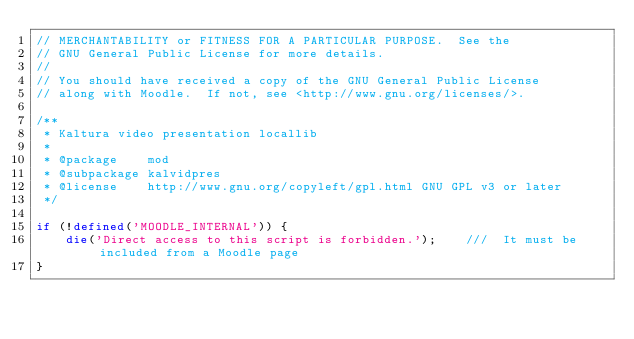Convert code to text. <code><loc_0><loc_0><loc_500><loc_500><_PHP_>// MERCHANTABILITY or FITNESS FOR A PARTICULAR PURPOSE.  See the
// GNU General Public License for more details.
//
// You should have received a copy of the GNU General Public License
// along with Moodle.  If not, see <http://www.gnu.org/licenses/>.

/**
 * Kaltura video presentation locallib
 *
 * @package    mod
 * @subpackage kalvidpres
 * @license    http://www.gnu.org/copyleft/gpl.html GNU GPL v3 or later
 */

if (!defined('MOODLE_INTERNAL')) {
    die('Direct access to this script is forbidden.');    ///  It must be included from a Moodle page
}

</code> 